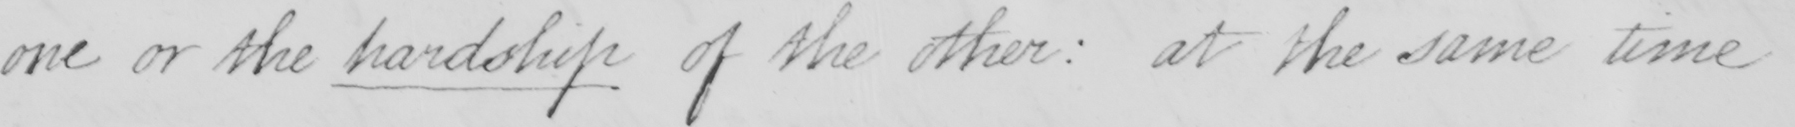Can you tell me what this handwritten text says? one or the hardship of the other  :  at the same time 